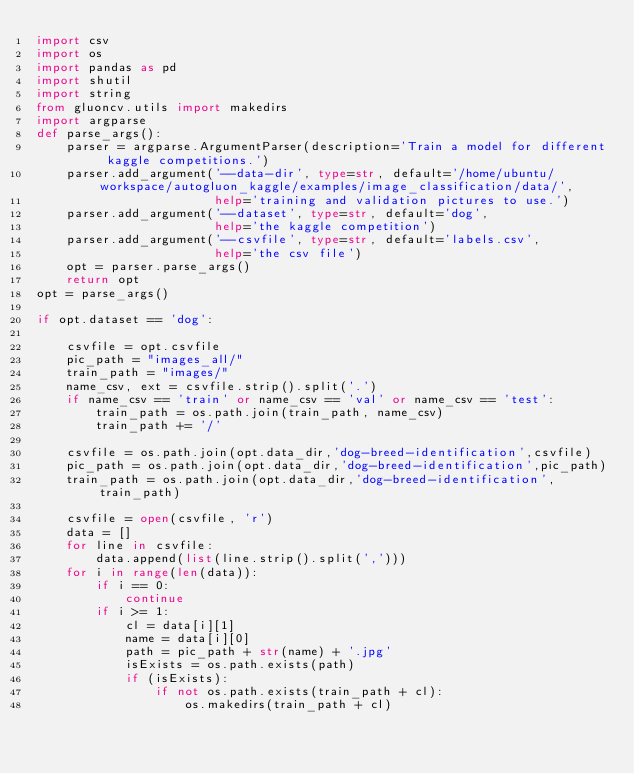<code> <loc_0><loc_0><loc_500><loc_500><_Python_>import csv
import os
import pandas as pd
import shutil
import string
from gluoncv.utils import makedirs
import argparse
def parse_args():
    parser = argparse.ArgumentParser(description='Train a model for different kaggle competitions.')
    parser.add_argument('--data-dir', type=str, default='/home/ubuntu/workspace/autogluon_kaggle/examples/image_classification/data/',
                        help='training and validation pictures to use.')
    parser.add_argument('--dataset', type=str, default='dog',
                        help='the kaggle competition')
    parser.add_argument('--csvfile', type=str, default='labels.csv',
                        help='the csv file')                    
    opt = parser.parse_args()
    return opt
opt = parse_args()

if opt.dataset == 'dog':

    csvfile = opt.csvfile
    pic_path = "images_all/"
    train_path = "images/"
    name_csv, ext = csvfile.strip().split('.')
    if name_csv == 'train' or name_csv == 'val' or name_csv == 'test':
        train_path = os.path.join(train_path, name_csv)
        train_path += '/'
    
    csvfile = os.path.join(opt.data_dir,'dog-breed-identification',csvfile)
    pic_path = os.path.join(opt.data_dir,'dog-breed-identification',pic_path)
    train_path = os.path.join(opt.data_dir,'dog-breed-identification',train_path)

    csvfile = open(csvfile, 'r')
    data = []
    for line in csvfile:
        data.append(list(line.strip().split(',')))
    for i in range(len(data)):
        if i == 0:
            continue
        if i >= 1:
            cl = data[i][1]
            name = data[i][0]
            path = pic_path + str(name) + '.jpg'
            isExists = os.path.exists(path)
            if (isExists):
                if not os.path.exists(train_path + cl):
                    os.makedirs(train_path + cl)</code> 